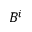<formula> <loc_0><loc_0><loc_500><loc_500>B ^ { i }</formula> 